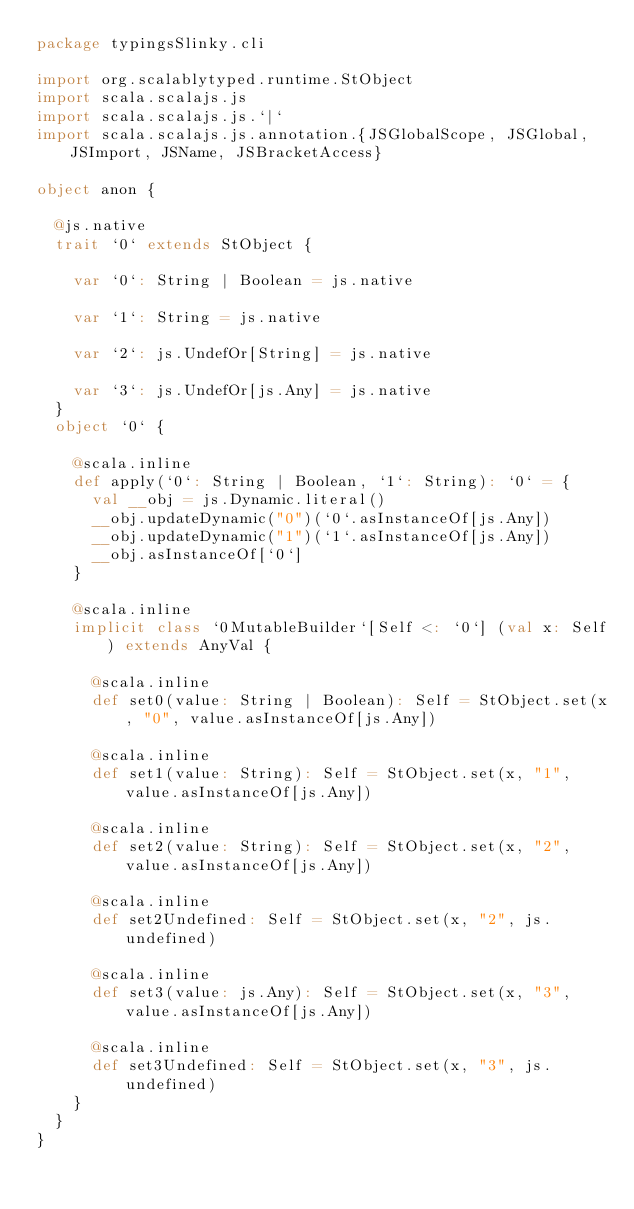Convert code to text. <code><loc_0><loc_0><loc_500><loc_500><_Scala_>package typingsSlinky.cli

import org.scalablytyped.runtime.StObject
import scala.scalajs.js
import scala.scalajs.js.`|`
import scala.scalajs.js.annotation.{JSGlobalScope, JSGlobal, JSImport, JSName, JSBracketAccess}

object anon {
  
  @js.native
  trait `0` extends StObject {
    
    var `0`: String | Boolean = js.native
    
    var `1`: String = js.native
    
    var `2`: js.UndefOr[String] = js.native
    
    var `3`: js.UndefOr[js.Any] = js.native
  }
  object `0` {
    
    @scala.inline
    def apply(`0`: String | Boolean, `1`: String): `0` = {
      val __obj = js.Dynamic.literal()
      __obj.updateDynamic("0")(`0`.asInstanceOf[js.Any])
      __obj.updateDynamic("1")(`1`.asInstanceOf[js.Any])
      __obj.asInstanceOf[`0`]
    }
    
    @scala.inline
    implicit class `0MutableBuilder`[Self <: `0`] (val x: Self) extends AnyVal {
      
      @scala.inline
      def set0(value: String | Boolean): Self = StObject.set(x, "0", value.asInstanceOf[js.Any])
      
      @scala.inline
      def set1(value: String): Self = StObject.set(x, "1", value.asInstanceOf[js.Any])
      
      @scala.inline
      def set2(value: String): Self = StObject.set(x, "2", value.asInstanceOf[js.Any])
      
      @scala.inline
      def set2Undefined: Self = StObject.set(x, "2", js.undefined)
      
      @scala.inline
      def set3(value: js.Any): Self = StObject.set(x, "3", value.asInstanceOf[js.Any])
      
      @scala.inline
      def set3Undefined: Self = StObject.set(x, "3", js.undefined)
    }
  }
}
</code> 